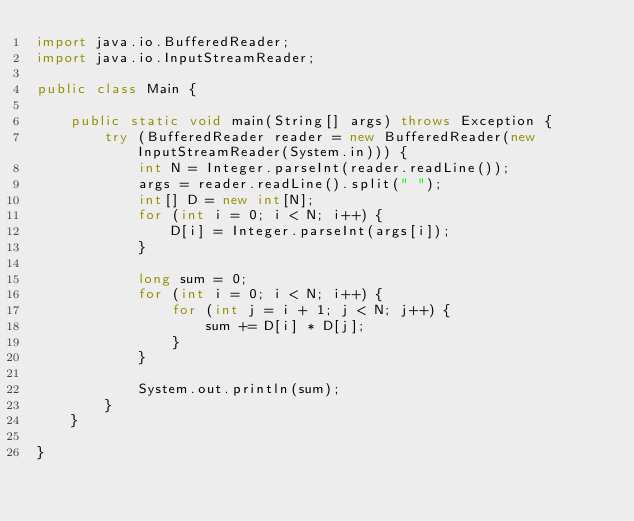Convert code to text. <code><loc_0><loc_0><loc_500><loc_500><_Java_>import java.io.BufferedReader;
import java.io.InputStreamReader;

public class Main {

    public static void main(String[] args) throws Exception {
        try (BufferedReader reader = new BufferedReader(new InputStreamReader(System.in))) {
            int N = Integer.parseInt(reader.readLine());
            args = reader.readLine().split(" ");
            int[] D = new int[N];
            for (int i = 0; i < N; i++) {
                D[i] = Integer.parseInt(args[i]);
            }

            long sum = 0;
            for (int i = 0; i < N; i++) {
                for (int j = i + 1; j < N; j++) {
                    sum += D[i] * D[j];
                }
            }

            System.out.println(sum);
        }
    }

}
</code> 